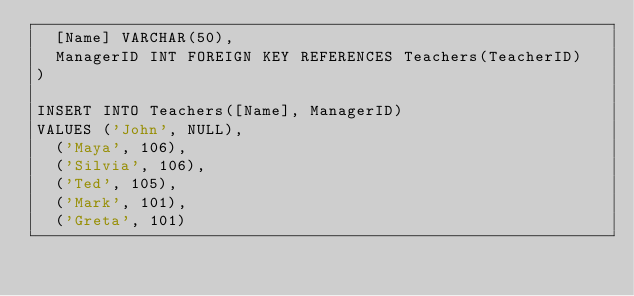<code> <loc_0><loc_0><loc_500><loc_500><_SQL_>	[Name] VARCHAR(50),
	ManagerID INT FOREIGN KEY REFERENCES Teachers(TeacherID)
)

INSERT INTO Teachers([Name], ManagerID)
VALUES ('John', NULL),
	('Maya', 106),
	('Silvia', 106),
	('Ted', 105),
	('Mark', 101),
	('Greta', 101)
</code> 